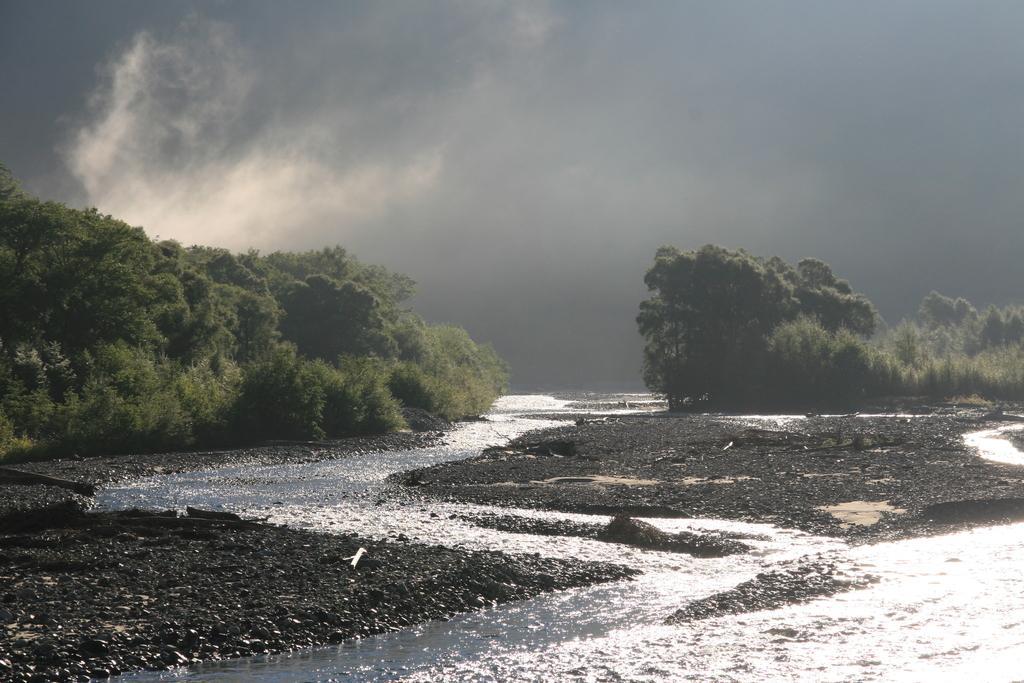How would you summarize this image in a sentence or two? We can see water. In the background we can see trees and sky is cloudy. 